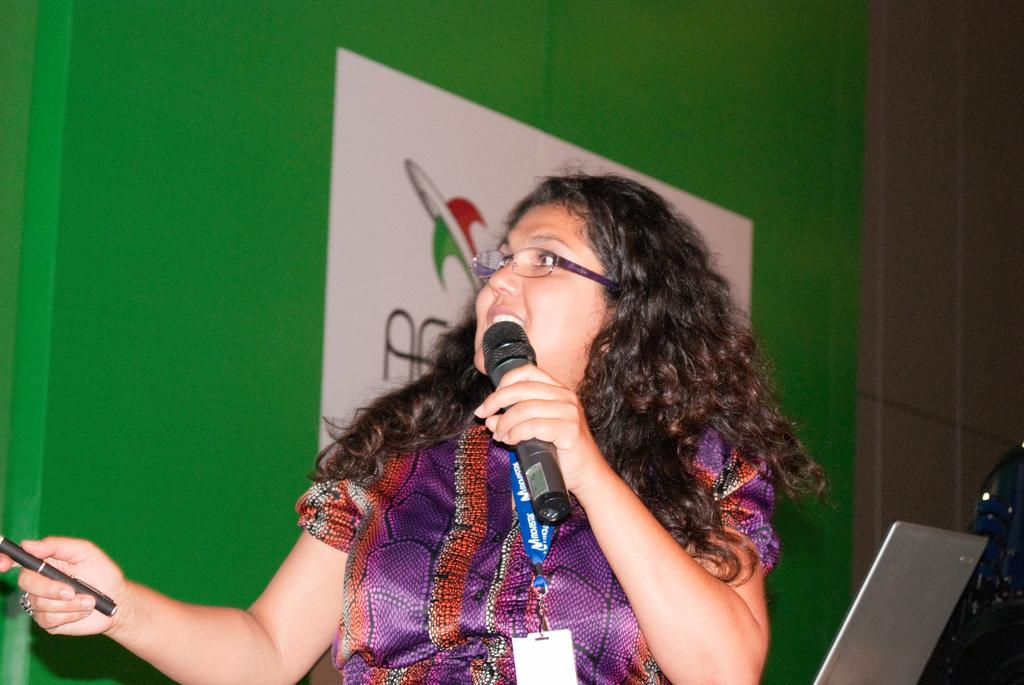Who is the main subject in the image? There is a woman in the image. What is the woman holding in her hand? The woman is holding a mic and a pen. What electronic device is visible in the image? There is a laptop in the image. What type of drug can be seen in the woman's hand in the image? There is no drug present in the image; the woman is holding a mic and a pen. What type of leaf is visible on the laptop in the image? There are no leaves visible on the laptop or anywhere else in the image. 